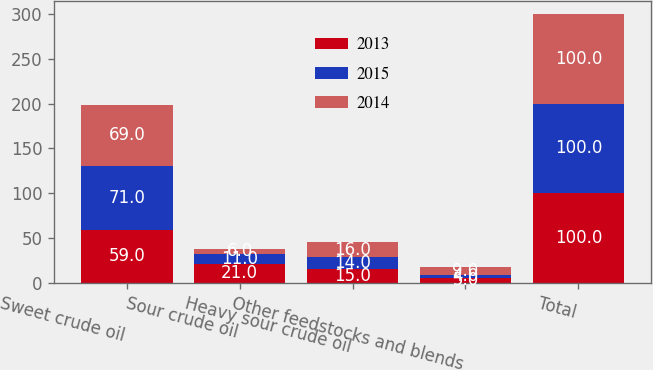<chart> <loc_0><loc_0><loc_500><loc_500><stacked_bar_chart><ecel><fcel>Sweet crude oil<fcel>Sour crude oil<fcel>Heavy sour crude oil<fcel>Other feedstocks and blends<fcel>Total<nl><fcel>2013<fcel>59<fcel>21<fcel>15<fcel>5<fcel>100<nl><fcel>2015<fcel>71<fcel>11<fcel>14<fcel>4<fcel>100<nl><fcel>2014<fcel>69<fcel>6<fcel>16<fcel>9<fcel>100<nl></chart> 